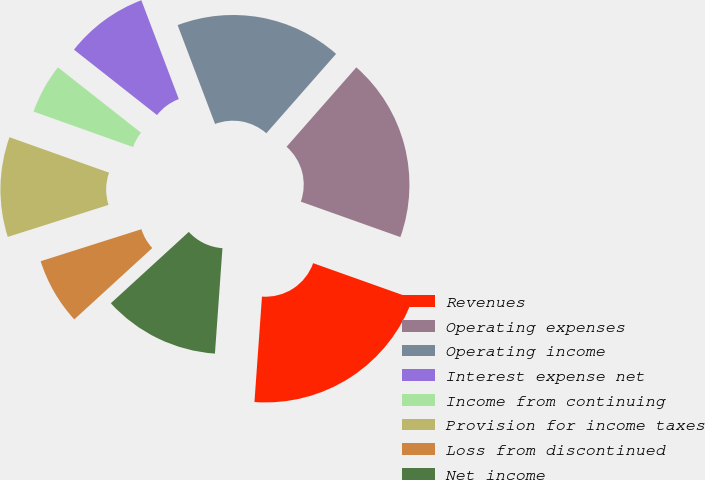Convert chart. <chart><loc_0><loc_0><loc_500><loc_500><pie_chart><fcel>Revenues<fcel>Operating expenses<fcel>Operating income<fcel>Interest expense net<fcel>Income from continuing<fcel>Provision for income taxes<fcel>Loss from discontinued<fcel>Net income<nl><fcel>20.69%<fcel>18.97%<fcel>17.24%<fcel>8.62%<fcel>5.17%<fcel>10.34%<fcel>6.9%<fcel>12.07%<nl></chart> 